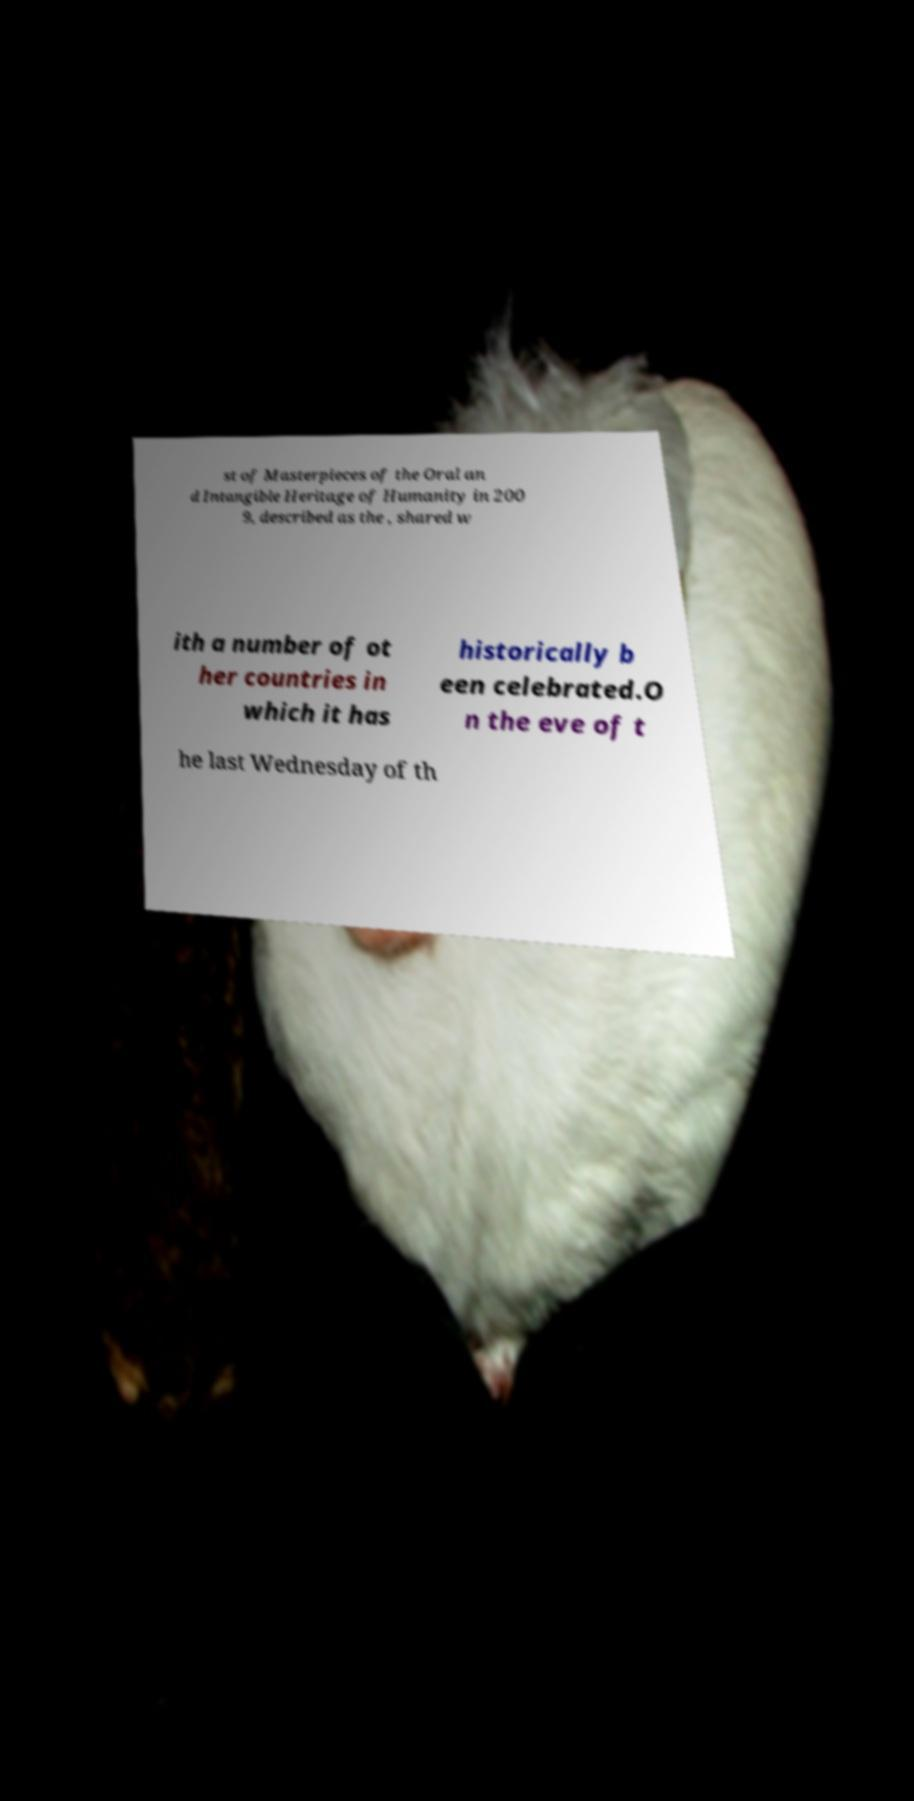I need the written content from this picture converted into text. Can you do that? st of Masterpieces of the Oral an d Intangible Heritage of Humanity in 200 9, described as the , shared w ith a number of ot her countries in which it has historically b een celebrated.O n the eve of t he last Wednesday of th 